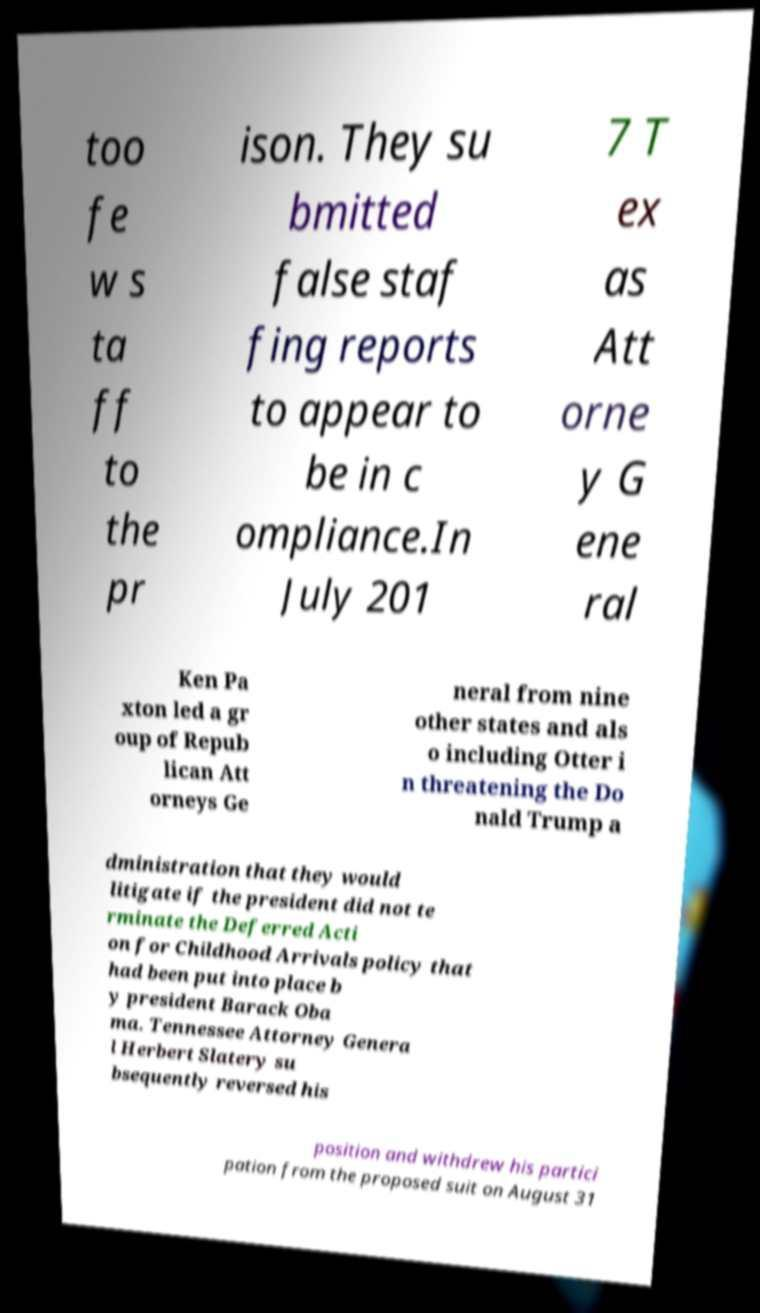There's text embedded in this image that I need extracted. Can you transcribe it verbatim? too fe w s ta ff to the pr ison. They su bmitted false staf fing reports to appear to be in c ompliance.In July 201 7 T ex as Att orne y G ene ral Ken Pa xton led a gr oup of Repub lican Att orneys Ge neral from nine other states and als o including Otter i n threatening the Do nald Trump a dministration that they would litigate if the president did not te rminate the Deferred Acti on for Childhood Arrivals policy that had been put into place b y president Barack Oba ma. Tennessee Attorney Genera l Herbert Slatery su bsequently reversed his position and withdrew his partici pation from the proposed suit on August 31 